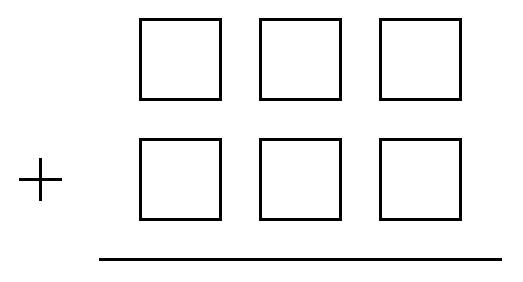What is the smallest sum of two $3$-digit numbers that can be obtained by placing each of the six digits $ 4,5,6,7,8,9 $ in one of the six boxes in this addition problem?

 Answer is 1047. 